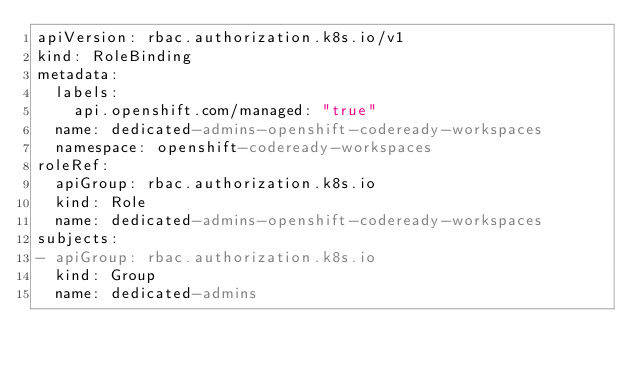<code> <loc_0><loc_0><loc_500><loc_500><_YAML_>apiVersion: rbac.authorization.k8s.io/v1
kind: RoleBinding
metadata:
  labels:
    api.openshift.com/managed: "true"
  name: dedicated-admins-openshift-codeready-workspaces
  namespace: openshift-codeready-workspaces
roleRef:
  apiGroup: rbac.authorization.k8s.io
  kind: Role
  name: dedicated-admins-openshift-codeready-workspaces
subjects:
- apiGroup: rbac.authorization.k8s.io
  kind: Group
  name: dedicated-admins
</code> 